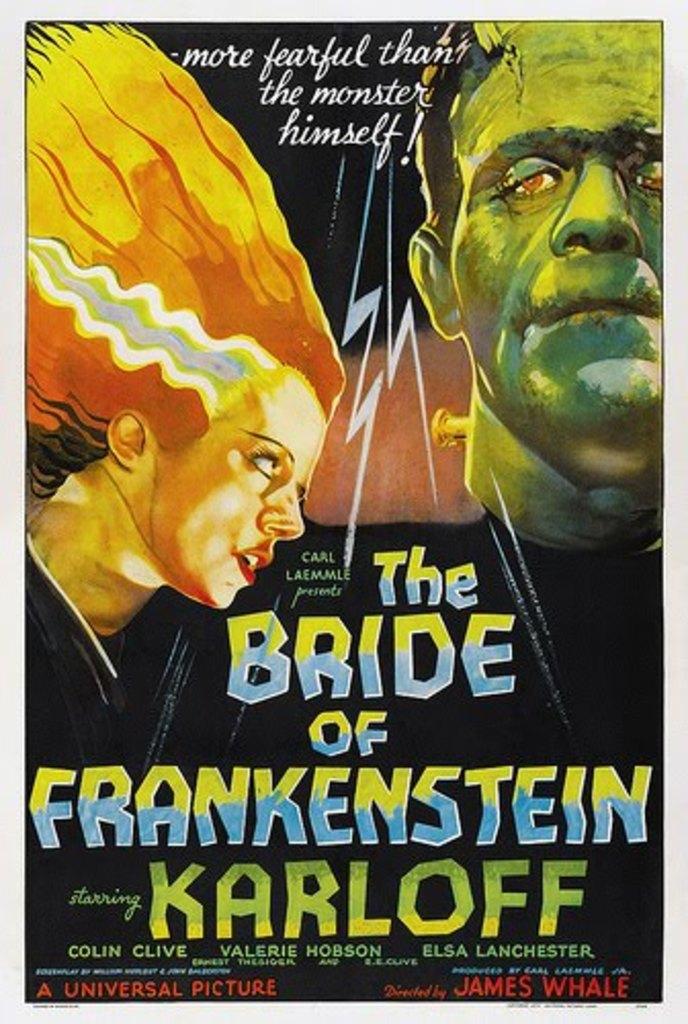Whose bride is featured?
Keep it short and to the point. Frankenstein. Who is the star of this movie?
Offer a terse response. Karloff. 